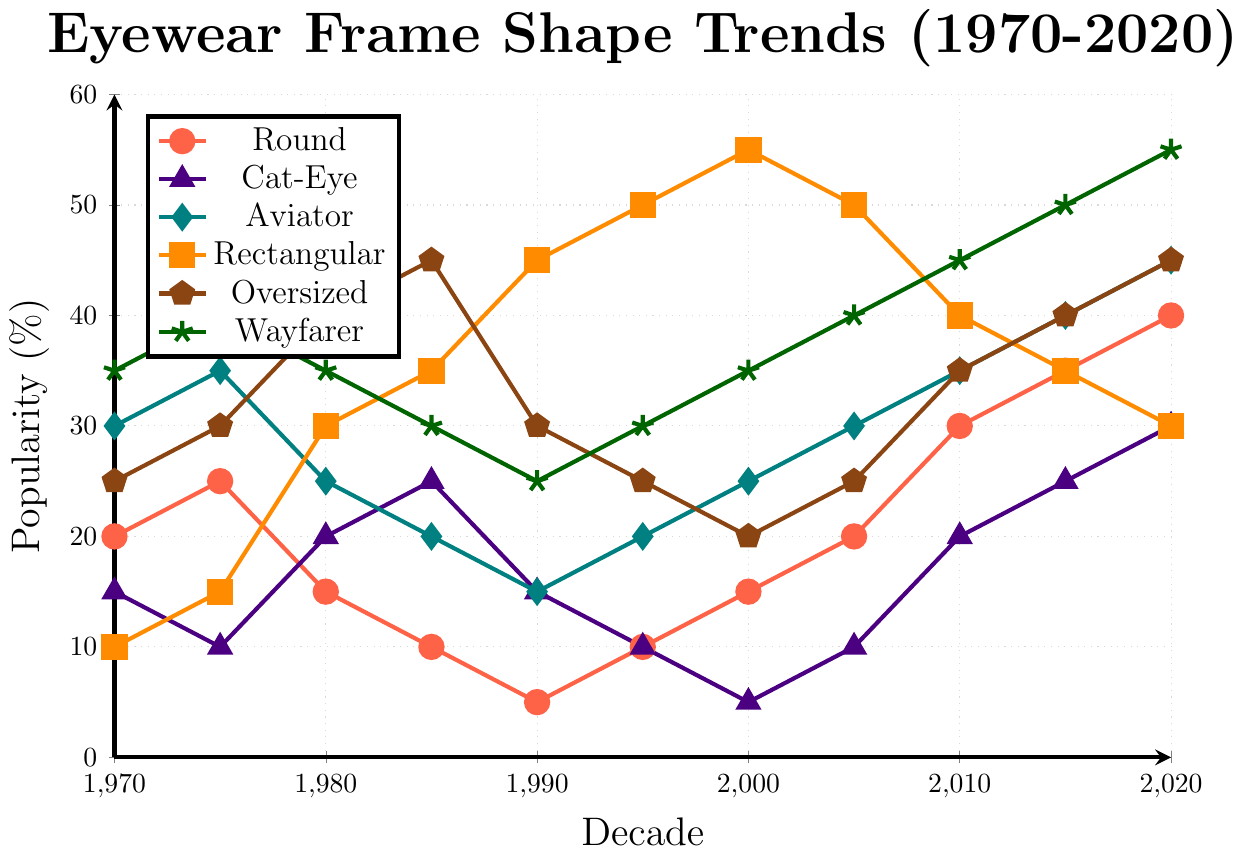Which frame shape was most popular in the 1970s? To find this, observe the y-axis values at the 1970 tick mark and identify the highest one. Wayfarer is at 35%, which is the tallest mark at this point.
Answer: Wayfarer How did the popularity of round frames change from the 1990s to the 2020s? Locate the round frames' data points at 1990 and 2020. The values are 5% and 40%, respectively. The change is calculated as 40% - 5% = 35%.
Answer: Increased by 35% Which frame shape saw the most consistent increase in popularity over the decades? Observe the trend lines for all frame shapes. Wayfarer shows a consistent increase from 35% in 1970 to 55% in 2020 without any dips.
Answer: Wayfarer In which decade did rectangular frames reach their peak popularity? Locate the maximum point on the rectangular frame’s trend line. The peak is at 55% in the 2000s.
Answer: 2000s Compare the popularity of cat-eye and aviator frames in the 1980s. Which was more popular and by how much? Locate the 1980 value for both frames: cat-eye is at 20%, and aviator is at 25%. The difference is calculated as 25% - 20% = 5%.
Answer: Aviator, by 5% What was the trend for oversized frames from the 1980s to the 1990s? Observe the oversized frame line from 1980 to 1990. The values decrease from 40% to 30%.
Answer: Decreased by 10% Which frame shape had the highest popularity in the 1980s? Observe all trend lines at the 1980 mark. Oversized is at 40%, the highest at this point.
Answer: Oversized By how much did the popularity of wayfarer frames increase from the 2010s to the 2020s? Locate the wayfarer values at 2010 and 2020. The values are 45% and 55%, respectively. The increase is 55% - 45% = 10%.
Answer: 10% Which frame shape experienced a peak in popularity in the 1990s and what was the value? Look for the highest point among 1990s data points. Rectangular frames peaked at 45%.
Answer: Rectangular, 45% Between 1990 and 2010, which frame shape's popularity showed an overall decreasing trend? Compare trends from 1990 to 2010. Cat-eye decreased from 15% to 20% with no intermediate increase.
Answer: Cat-Eye 